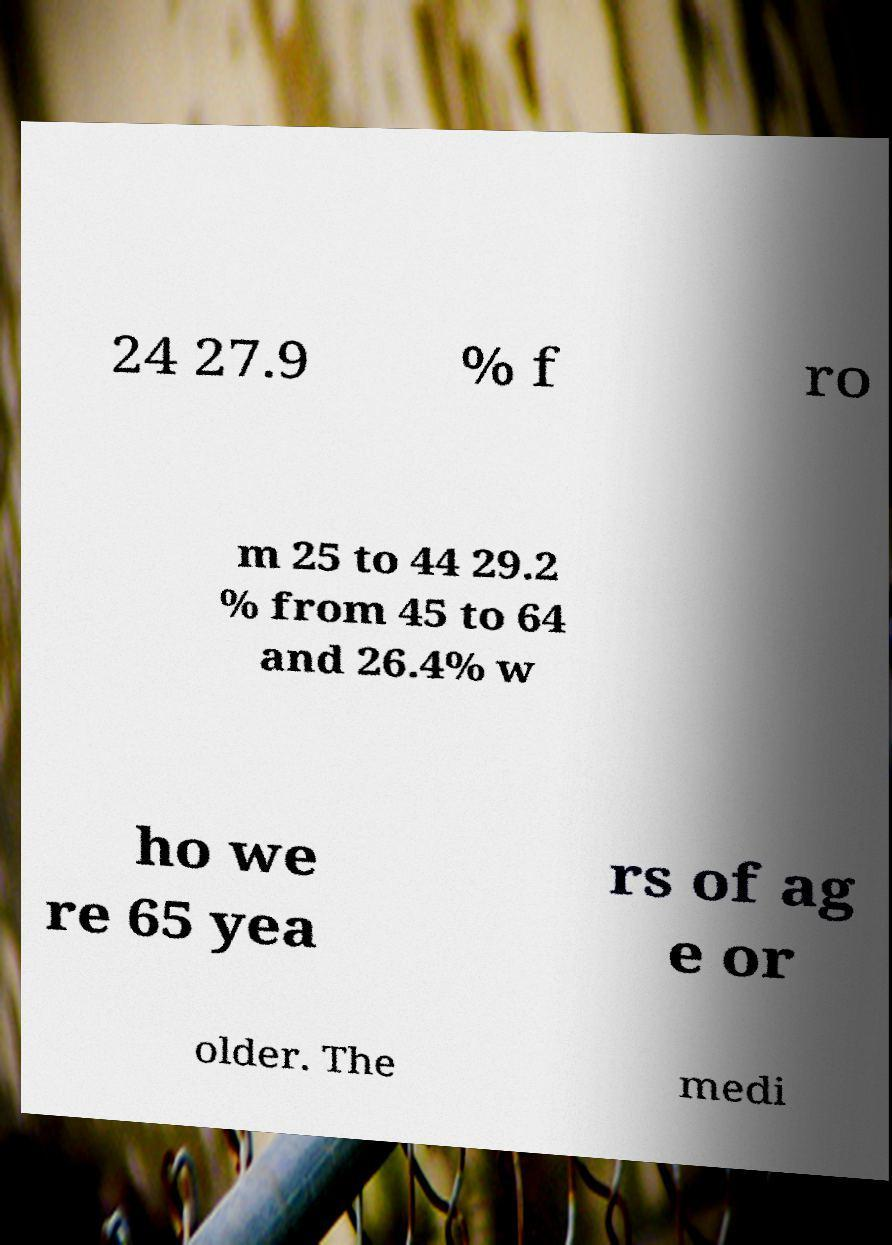For documentation purposes, I need the text within this image transcribed. Could you provide that? 24 27.9 % f ro m 25 to 44 29.2 % from 45 to 64 and 26.4% w ho we re 65 yea rs of ag e or older. The medi 